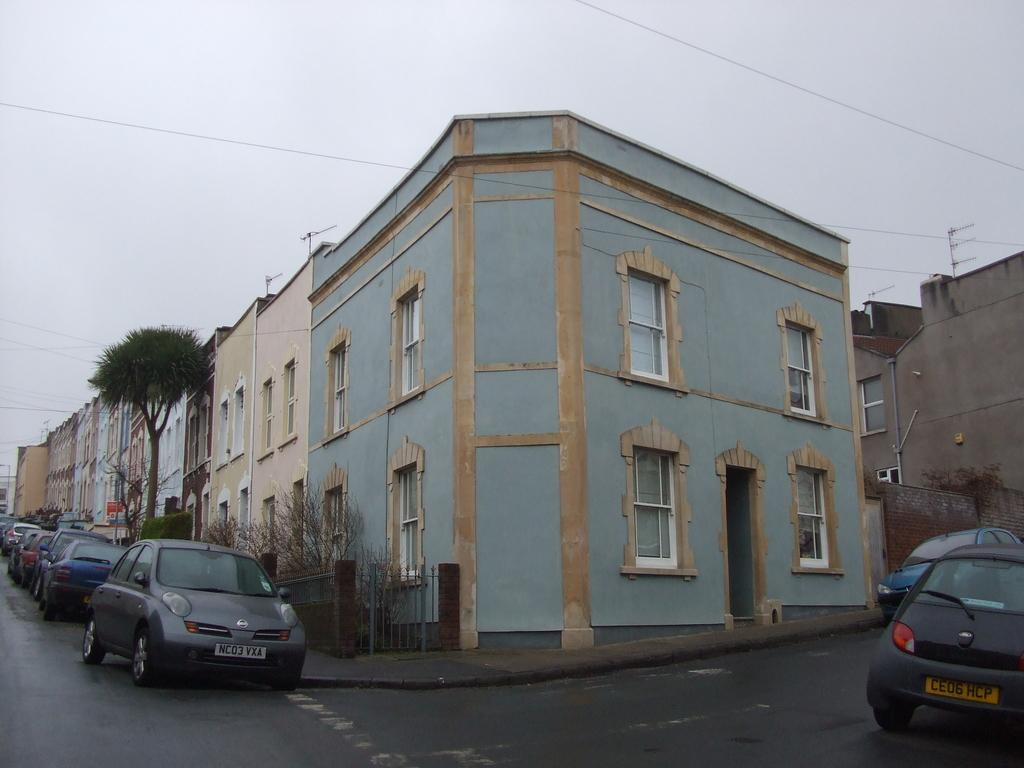What type of structures can be seen in the image? There are buildings in the image. What else can be seen on the road in the image? There are vehicles parked on the road in the image. What can be seen in the distance in the image? There are trees in the background of the image. What is visible above the buildings and trees in the image? The sky is visible in the background of the image. What type of test is being conducted on the buildings in the image? There is no indication of a test being conducted on the buildings in the image. 